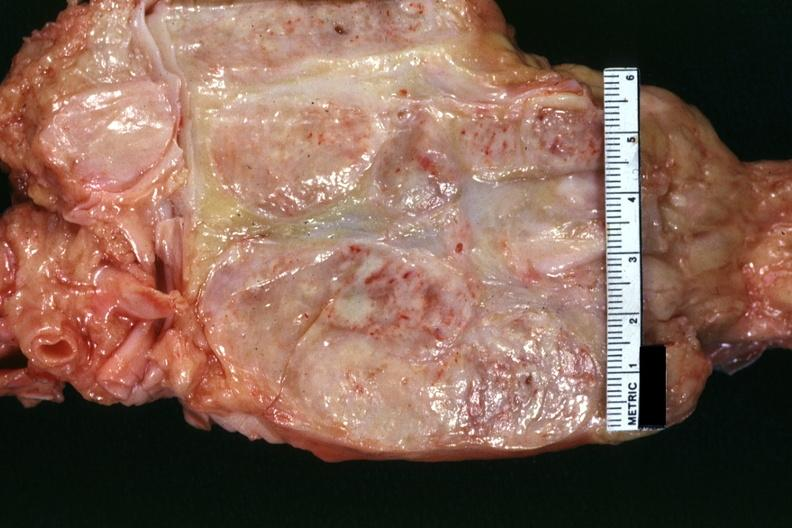how does surface of nodes seen externally in slide show matting and necrosis?
Answer the question using a single word or phrase. Focal 